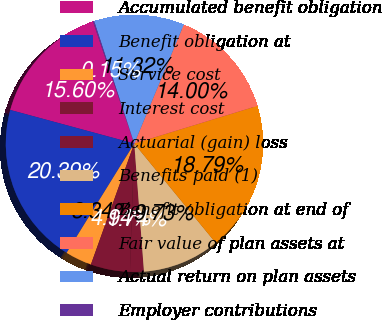<chart> <loc_0><loc_0><loc_500><loc_500><pie_chart><fcel>Accumulated benefit obligation<fcel>Benefit obligation at<fcel>Service cost<fcel>Interest cost<fcel>Actuarial (gain) loss<fcel>Benefits paid (1)<fcel>Benefit obligation at end of<fcel>Fair value of plan assets at<fcel>Actual return on plan assets<fcel>Employer contributions<nl><fcel>15.6%<fcel>20.39%<fcel>3.34%<fcel>4.94%<fcel>1.74%<fcel>9.73%<fcel>18.79%<fcel>14.0%<fcel>11.32%<fcel>0.15%<nl></chart> 